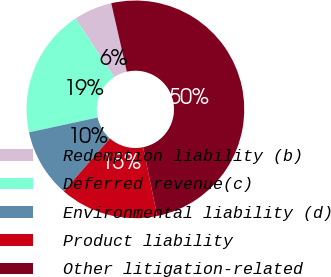<chart> <loc_0><loc_0><loc_500><loc_500><pie_chart><fcel>Redemption liability (b)<fcel>Deferred revenue(c)<fcel>Environmental liability (d)<fcel>Product liability<fcel>Other litigation-related<nl><fcel>5.72%<fcel>19.11%<fcel>10.18%<fcel>14.64%<fcel>50.35%<nl></chart> 